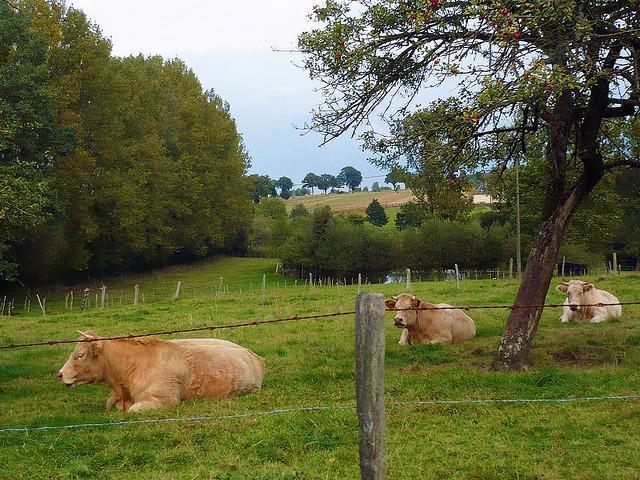How many cows are standing?
Give a very brief answer. 0. How many cows can be seen?
Give a very brief answer. 2. How many people are wearing a hat in the picture?
Give a very brief answer. 0. 